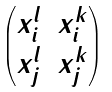Convert formula to latex. <formula><loc_0><loc_0><loc_500><loc_500>\begin{pmatrix} x _ { i } ^ { l } & x _ { i } ^ { k } \\ x _ { j } ^ { l } & x _ { j } ^ { k } \end{pmatrix}</formula> 